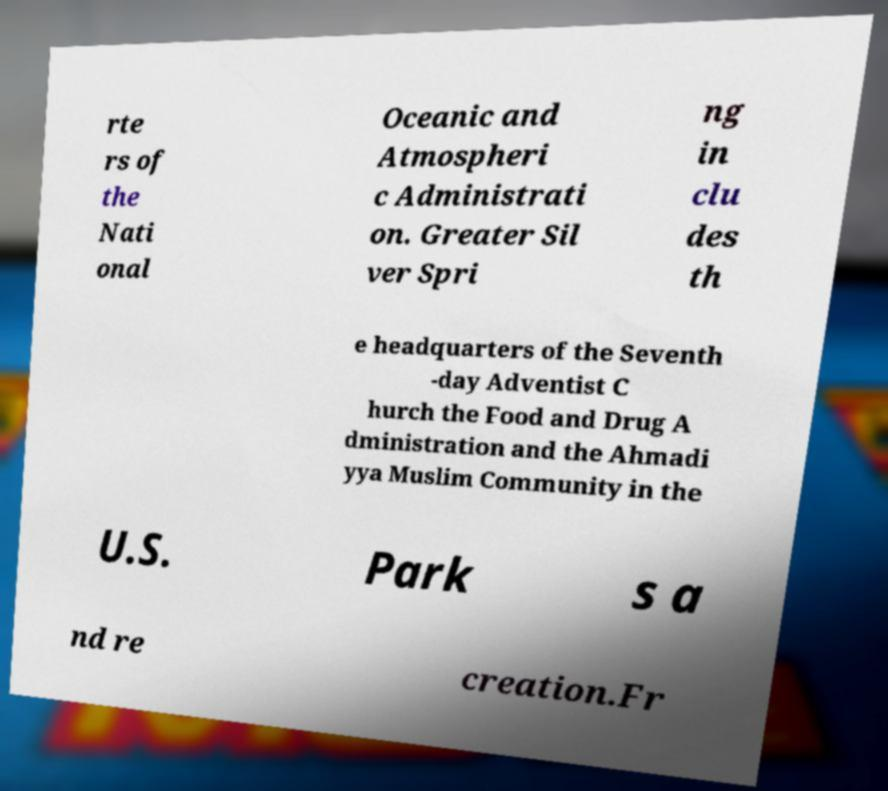What messages or text are displayed in this image? I need them in a readable, typed format. rte rs of the Nati onal Oceanic and Atmospheri c Administrati on. Greater Sil ver Spri ng in clu des th e headquarters of the Seventh -day Adventist C hurch the Food and Drug A dministration and the Ahmadi yya Muslim Community in the U.S. Park s a nd re creation.Fr 